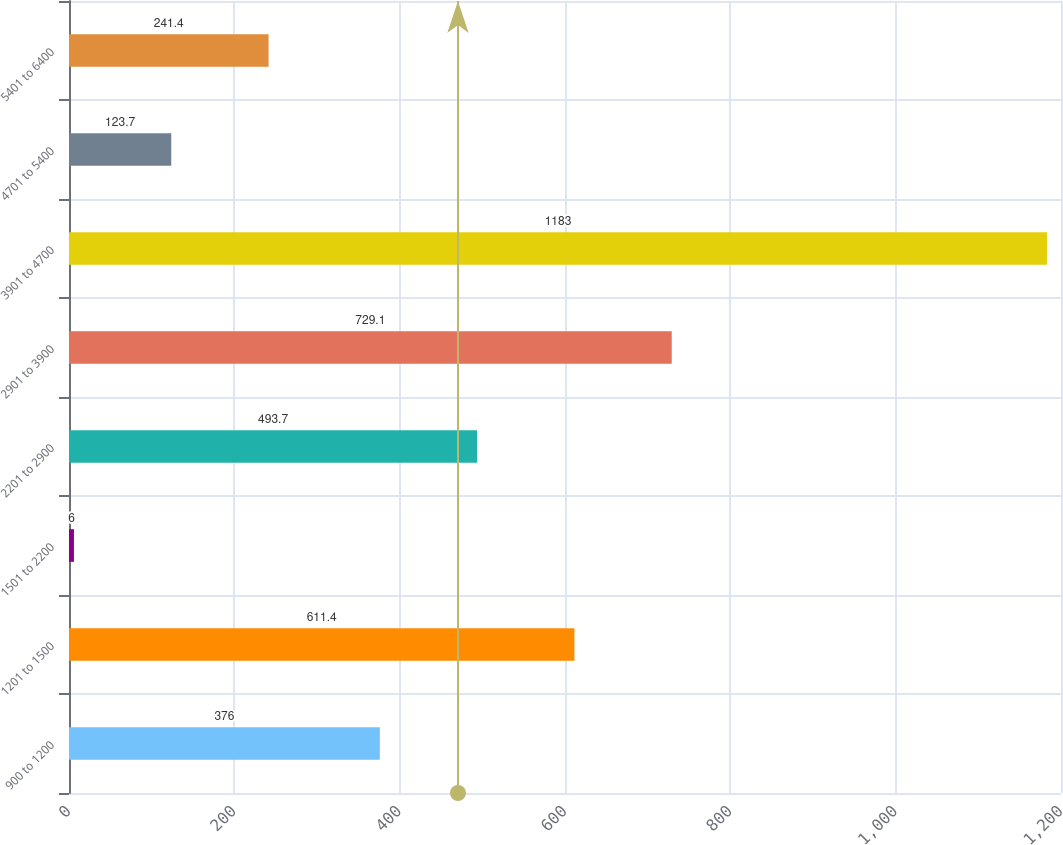Convert chart to OTSL. <chart><loc_0><loc_0><loc_500><loc_500><bar_chart><fcel>900 to 1200<fcel>1201 to 1500<fcel>1501 to 2200<fcel>2201 to 2900<fcel>2901 to 3900<fcel>3901 to 4700<fcel>4701 to 5400<fcel>5401 to 6400<nl><fcel>376<fcel>611.4<fcel>6<fcel>493.7<fcel>729.1<fcel>1183<fcel>123.7<fcel>241.4<nl></chart> 